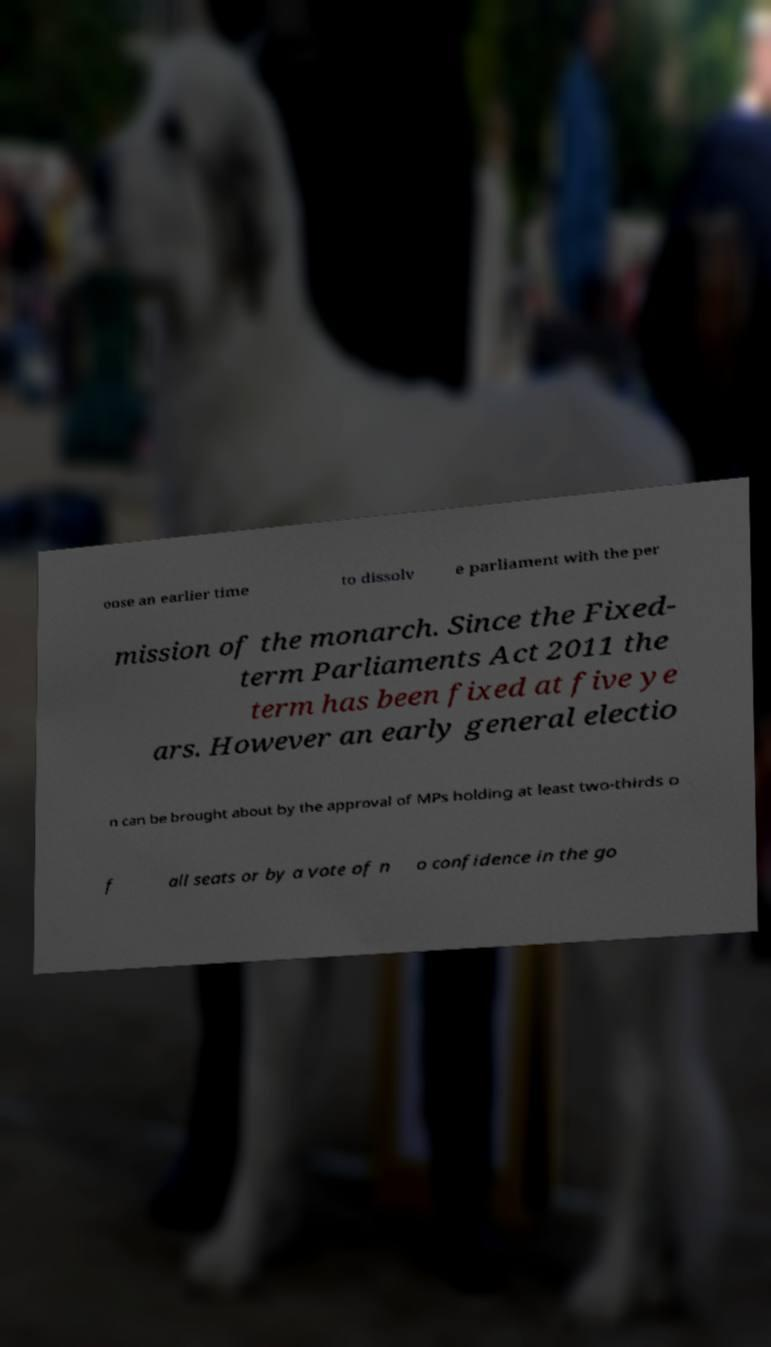Could you assist in decoding the text presented in this image and type it out clearly? oose an earlier time to dissolv e parliament with the per mission of the monarch. Since the Fixed- term Parliaments Act 2011 the term has been fixed at five ye ars. However an early general electio n can be brought about by the approval of MPs holding at least two-thirds o f all seats or by a vote of n o confidence in the go 